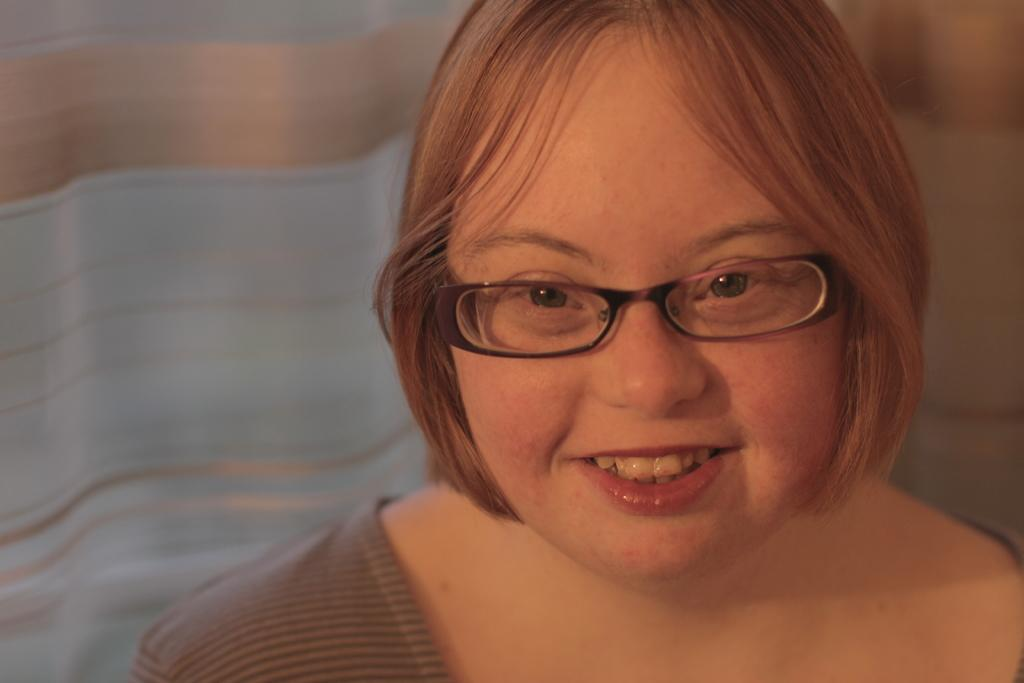Who is the main subject in the image? There is a woman in the image. Where is the woman located in the image? The woman is on the right side of the image. What is the woman wearing on her face? The woman is wearing goggles. What type of pin can be seen holding the sheep's argument together in the image? There is no pin, sheep, or argument present in the image. 